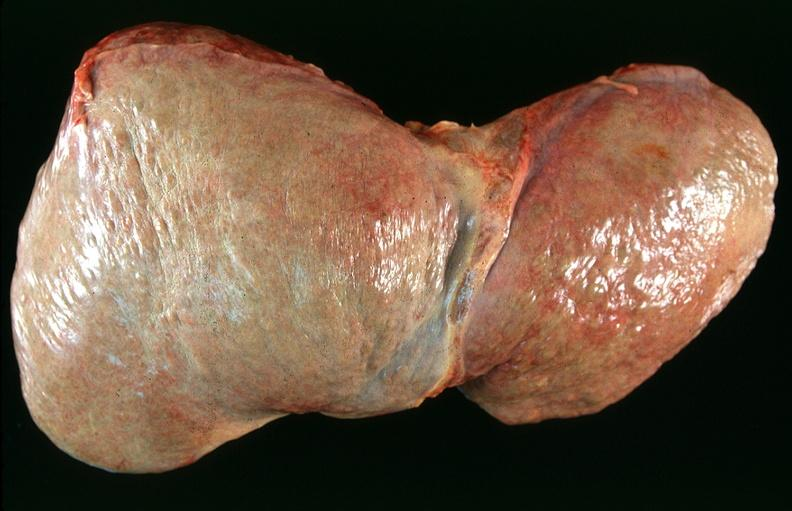does krukenberg tumor show liver, cirrhosis alpha-1 antitrypsin deficiency?
Answer the question using a single word or phrase. No 